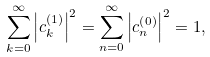Convert formula to latex. <formula><loc_0><loc_0><loc_500><loc_500>\sum _ { k = 0 } ^ { \infty } \left | c _ { k } ^ { \left ( 1 \right ) } \right | ^ { 2 } = \sum _ { n = 0 } ^ { \infty } \left | c _ { n } ^ { \left ( 0 \right ) } \right | ^ { 2 } = 1 ,</formula> 